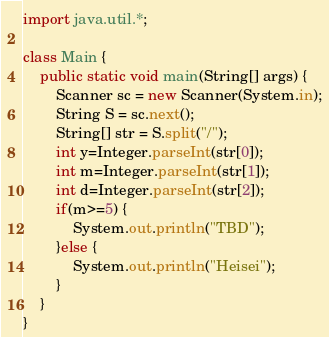<code> <loc_0><loc_0><loc_500><loc_500><_Java_>import java.util.*;

class Main {
	public static void main(String[] args) {
		Scanner sc = new Scanner(System.in);
		String S = sc.next();
		String[] str = S.split("/");
		int y=Integer.parseInt(str[0]);
		int m=Integer.parseInt(str[1]);
		int d=Integer.parseInt(str[2]);
		if(m>=5) {
			System.out.println("TBD");
		}else {
			System.out.println("Heisei");
		}
	}
}</code> 